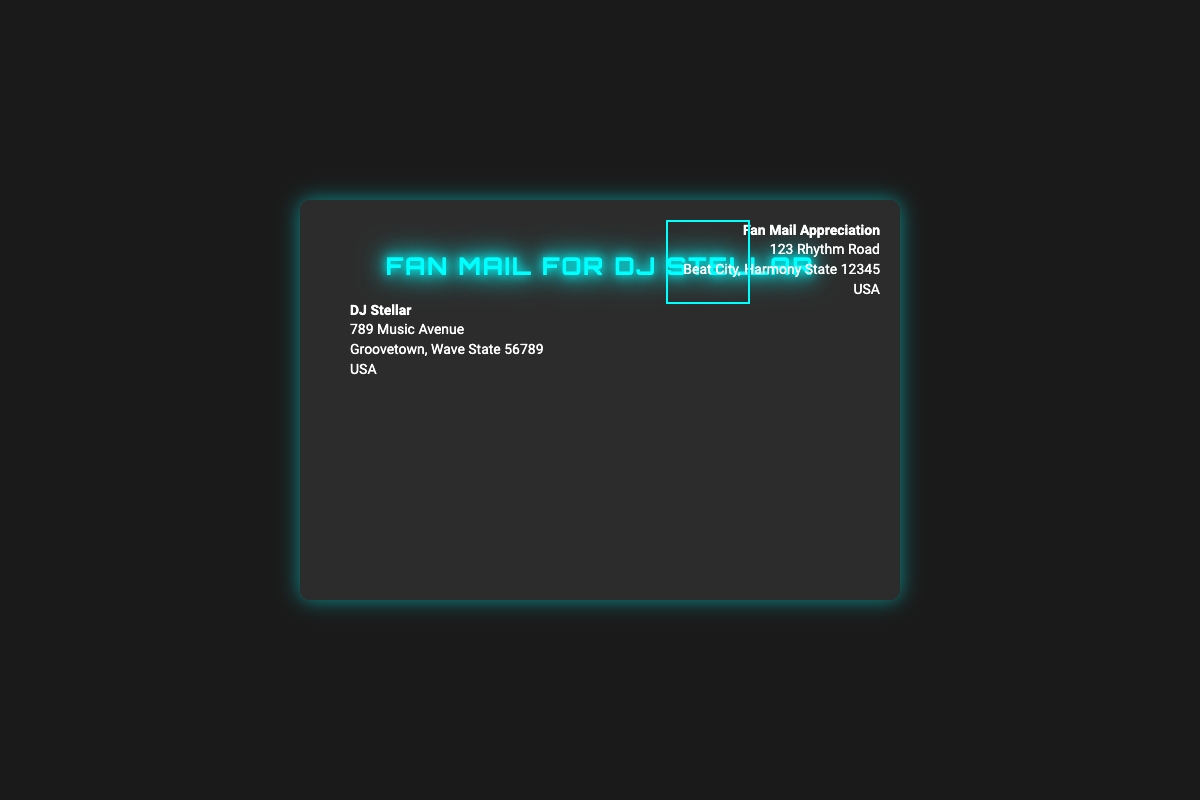What is the recipient's name? The recipient's name is located at the top of the address section on the envelope's front.
Answer: DJ Stellar What is the address of the sender? The sender's address can be found in the address section on the front of the envelope.
Answer: 123 Rhythm Road, Beat City, Harmony State 12345, USA What color is the envelope background? The background color of the envelope is specified in the style section of the code.
Answer: Dark gray What theme is represented by the decorative images? The decorative images include elements that relate to music, signifying the DJ theme of the envelope.
Answer: DJ theme What is the title of the envelope? The title is prominently displayed on the front of the envelope, indicated by the styled text.
Answer: Fan Mail for DJ Stellar How many addresses are listed on the envelope? The envelope contains two addresses: one for the recipient and one for the sender.
Answer: Two What is the significance of the fan art? The fan art is a visual representation included to celebrate the artist and represents fan appreciation.
Answer: Fan appreciation What shape is the seal on the back of the envelope? The seal's description indicates its geometric form, which is noted in the relevant section.
Answer: Star-shaped What does the stamp feature? The stamp's description specifies that it highlights DJ Stellar's logo, which adds a personalized touch.
Answer: DJ Stellar's logo 